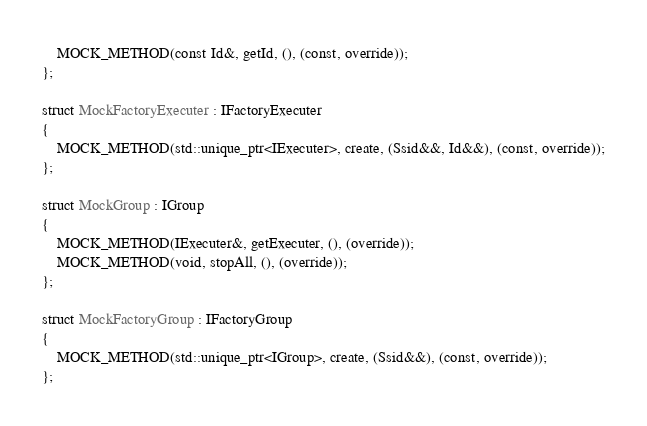<code> <loc_0><loc_0><loc_500><loc_500><_C_>    MOCK_METHOD(const Id&, getId, (), (const, override));
};

struct MockFactoryExecuter : IFactoryExecuter
{
    MOCK_METHOD(std::unique_ptr<IExecuter>, create, (Ssid&&, Id&&), (const, override));
};

struct MockGroup : IGroup
{
    MOCK_METHOD(IExecuter&, getExecuter, (), (override));
    MOCK_METHOD(void, stopAll, (), (override));
};

struct MockFactoryGroup : IFactoryGroup
{
    MOCK_METHOD(std::unique_ptr<IGroup>, create, (Ssid&&), (const, override));
};
</code> 